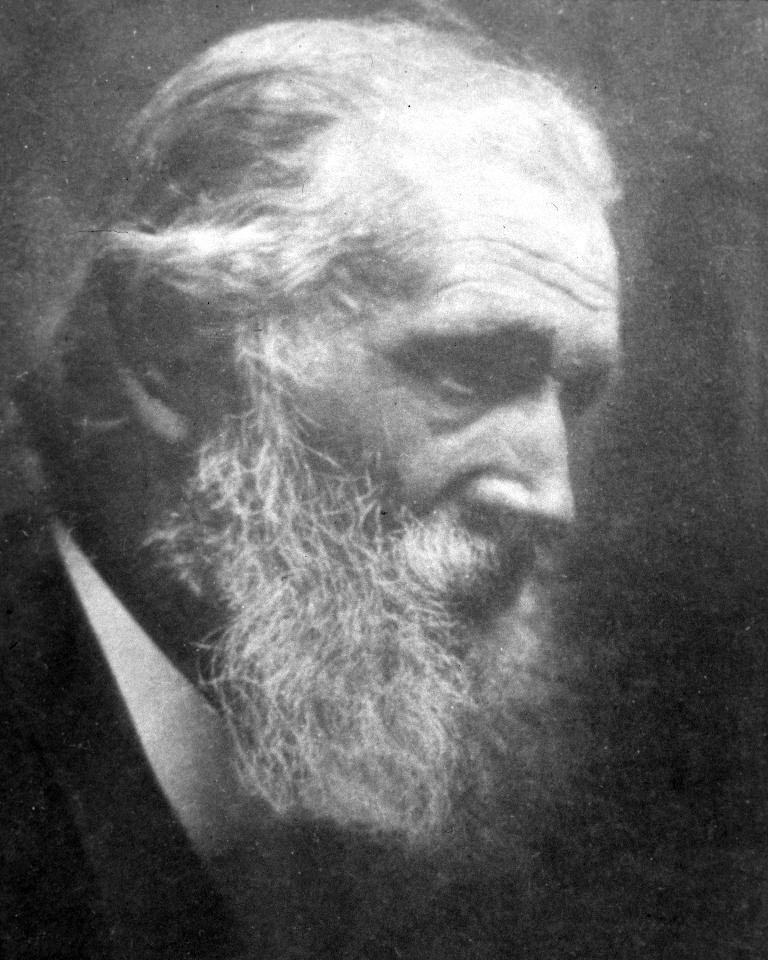What is the color scheme of the image? The image is black and white. Can you describe the person in the image? There is an old person in the image. What type of offer is the old person making in the image? There is no offer being made in the image; it only features an old person. How many lizards can be seen interacting with the old person in the image? There are no lizards present in the image. 